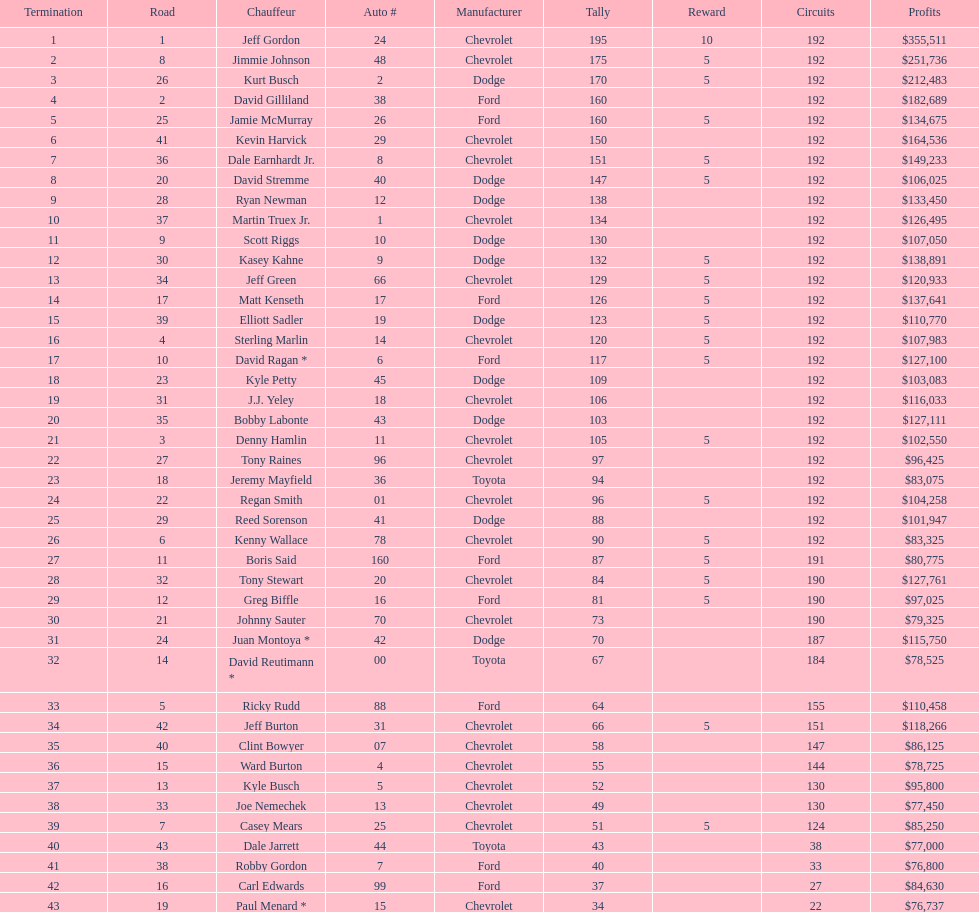How many drivers placed below tony stewart? 15. Parse the table in full. {'header': ['Termination', 'Road', 'Chauffeur', 'Auto #', 'Manufacturer', 'Tally', 'Reward', 'Circuits', 'Profits'], 'rows': [['1', '1', 'Jeff Gordon', '24', 'Chevrolet', '195', '10', '192', '$355,511'], ['2', '8', 'Jimmie Johnson', '48', 'Chevrolet', '175', '5', '192', '$251,736'], ['3', '26', 'Kurt Busch', '2', 'Dodge', '170', '5', '192', '$212,483'], ['4', '2', 'David Gilliland', '38', 'Ford', '160', '', '192', '$182,689'], ['5', '25', 'Jamie McMurray', '26', 'Ford', '160', '5', '192', '$134,675'], ['6', '41', 'Kevin Harvick', '29', 'Chevrolet', '150', '', '192', '$164,536'], ['7', '36', 'Dale Earnhardt Jr.', '8', 'Chevrolet', '151', '5', '192', '$149,233'], ['8', '20', 'David Stremme', '40', 'Dodge', '147', '5', '192', '$106,025'], ['9', '28', 'Ryan Newman', '12', 'Dodge', '138', '', '192', '$133,450'], ['10', '37', 'Martin Truex Jr.', '1', 'Chevrolet', '134', '', '192', '$126,495'], ['11', '9', 'Scott Riggs', '10', 'Dodge', '130', '', '192', '$107,050'], ['12', '30', 'Kasey Kahne', '9', 'Dodge', '132', '5', '192', '$138,891'], ['13', '34', 'Jeff Green', '66', 'Chevrolet', '129', '5', '192', '$120,933'], ['14', '17', 'Matt Kenseth', '17', 'Ford', '126', '5', '192', '$137,641'], ['15', '39', 'Elliott Sadler', '19', 'Dodge', '123', '5', '192', '$110,770'], ['16', '4', 'Sterling Marlin', '14', 'Chevrolet', '120', '5', '192', '$107,983'], ['17', '10', 'David Ragan *', '6', 'Ford', '117', '5', '192', '$127,100'], ['18', '23', 'Kyle Petty', '45', 'Dodge', '109', '', '192', '$103,083'], ['19', '31', 'J.J. Yeley', '18', 'Chevrolet', '106', '', '192', '$116,033'], ['20', '35', 'Bobby Labonte', '43', 'Dodge', '103', '', '192', '$127,111'], ['21', '3', 'Denny Hamlin', '11', 'Chevrolet', '105', '5', '192', '$102,550'], ['22', '27', 'Tony Raines', '96', 'Chevrolet', '97', '', '192', '$96,425'], ['23', '18', 'Jeremy Mayfield', '36', 'Toyota', '94', '', '192', '$83,075'], ['24', '22', 'Regan Smith', '01', 'Chevrolet', '96', '5', '192', '$104,258'], ['25', '29', 'Reed Sorenson', '41', 'Dodge', '88', '', '192', '$101,947'], ['26', '6', 'Kenny Wallace', '78', 'Chevrolet', '90', '5', '192', '$83,325'], ['27', '11', 'Boris Said', '160', 'Ford', '87', '5', '191', '$80,775'], ['28', '32', 'Tony Stewart', '20', 'Chevrolet', '84', '5', '190', '$127,761'], ['29', '12', 'Greg Biffle', '16', 'Ford', '81', '5', '190', '$97,025'], ['30', '21', 'Johnny Sauter', '70', 'Chevrolet', '73', '', '190', '$79,325'], ['31', '24', 'Juan Montoya *', '42', 'Dodge', '70', '', '187', '$115,750'], ['32', '14', 'David Reutimann *', '00', 'Toyota', '67', '', '184', '$78,525'], ['33', '5', 'Ricky Rudd', '88', 'Ford', '64', '', '155', '$110,458'], ['34', '42', 'Jeff Burton', '31', 'Chevrolet', '66', '5', '151', '$118,266'], ['35', '40', 'Clint Bowyer', '07', 'Chevrolet', '58', '', '147', '$86,125'], ['36', '15', 'Ward Burton', '4', 'Chevrolet', '55', '', '144', '$78,725'], ['37', '13', 'Kyle Busch', '5', 'Chevrolet', '52', '', '130', '$95,800'], ['38', '33', 'Joe Nemechek', '13', 'Chevrolet', '49', '', '130', '$77,450'], ['39', '7', 'Casey Mears', '25', 'Chevrolet', '51', '5', '124', '$85,250'], ['40', '43', 'Dale Jarrett', '44', 'Toyota', '43', '', '38', '$77,000'], ['41', '38', 'Robby Gordon', '7', 'Ford', '40', '', '33', '$76,800'], ['42', '16', 'Carl Edwards', '99', 'Ford', '37', '', '27', '$84,630'], ['43', '19', 'Paul Menard *', '15', 'Chevrolet', '34', '', '22', '$76,737']]} 